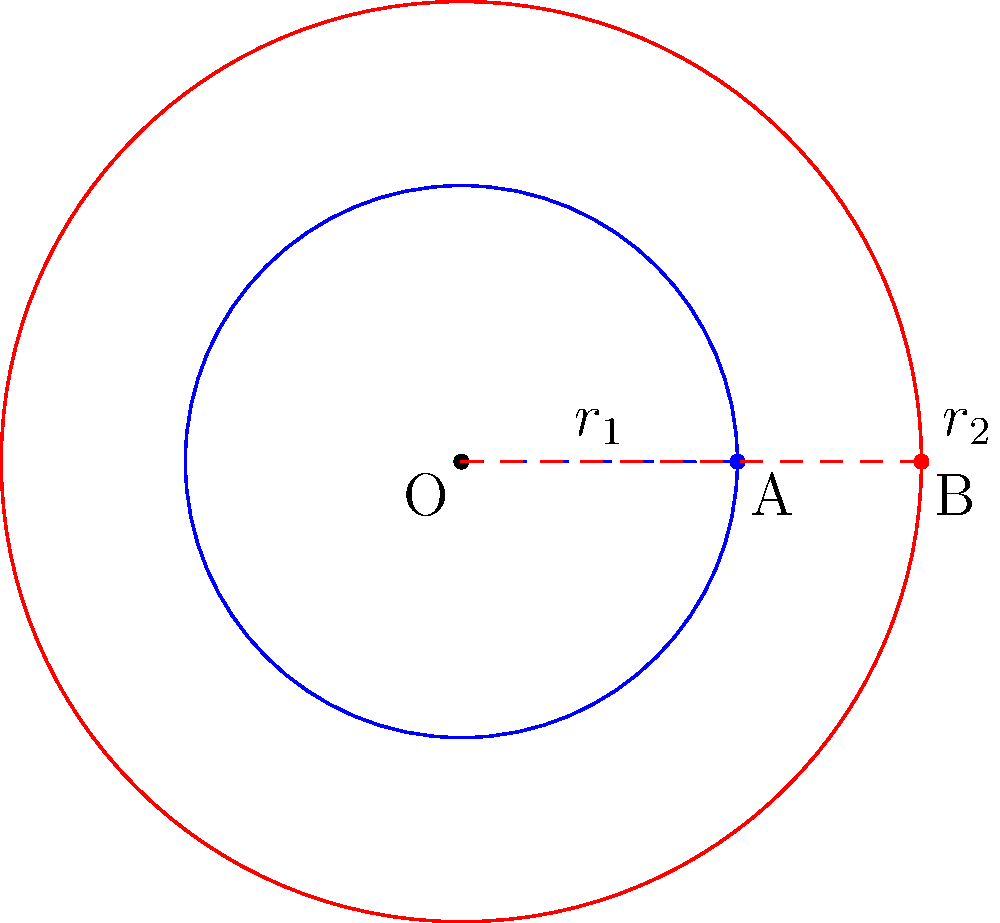In a binary star system, two stars orbit their common center of mass O in circular orbits. Star A has an orbital radius $r_1 = 3$ AU and completes one revolution in 1 year. Star B has an orbital radius $r_2 = 5$ AU. Assuming both stars follow Kepler's laws of planetary motion, what is the orbital period of star B in years? To solve this problem, we'll use Kepler's Third Law of planetary motion, which states that the square of the orbital period is proportional to the cube of the semi-major axis (in this case, the radius of the circular orbit).

Step 1: Let's define the variables:
$T_1 = 1$ year (period of star A)
$r_1 = 3$ AU (radius of star A's orbit)
$T_2 = $ unknown (period of star B)
$r_2 = 5$ AU (radius of star B's orbit)

Step 2: Apply Kepler's Third Law:
$$\frac{T_1^2}{r_1^3} = \frac{T_2^2}{r_2^3}$$

Step 3: Substitute the known values:
$$\frac{1^2}{3^3} = \frac{T_2^2}{5^3}$$

Step 4: Simplify:
$$\frac{1}{27} = \frac{T_2^2}{125}$$

Step 5: Solve for $T_2$:
$$T_2^2 = \frac{125}{27}$$
$$T_2 = \sqrt{\frac{125}{27}} \approx 2.15$$

Therefore, the orbital period of star B is approximately 2.15 years.
Answer: 2.15 years 